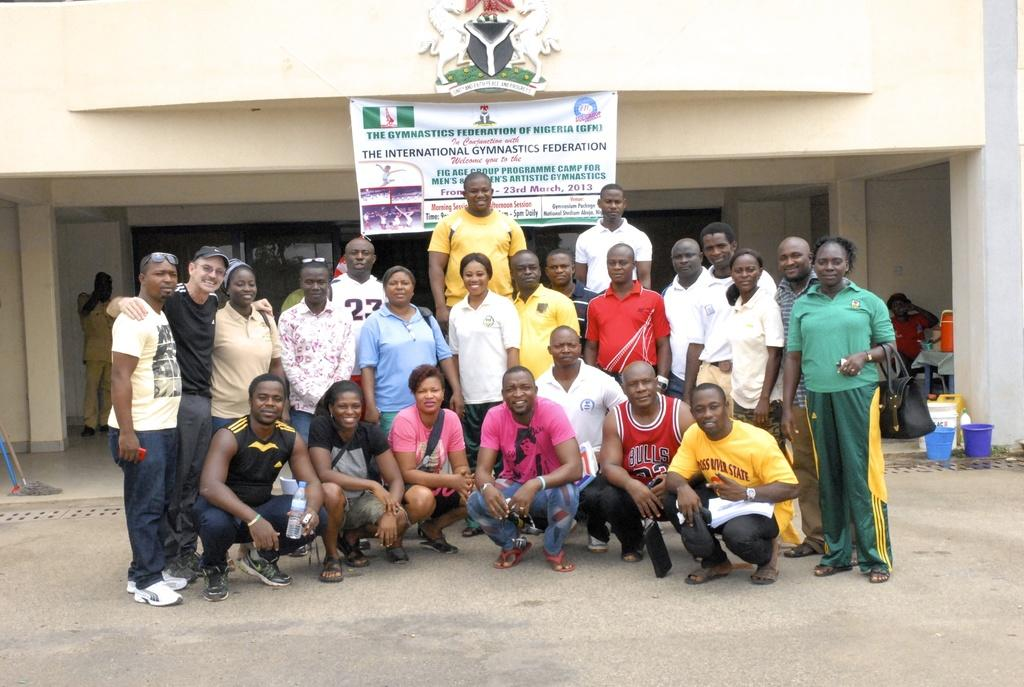How many people are in the image? There is a group of people in the image. What are the people in the image doing? Some people are standing, while others are in a squat position on the ground. What can be seen in the background of the image? There is a banner and buckets visible in the background of the image. Can you give an example of a thumb in the image? There is no thumb present in the image. What type of wren can be seen flying in the image? There is no wren present in the image. 